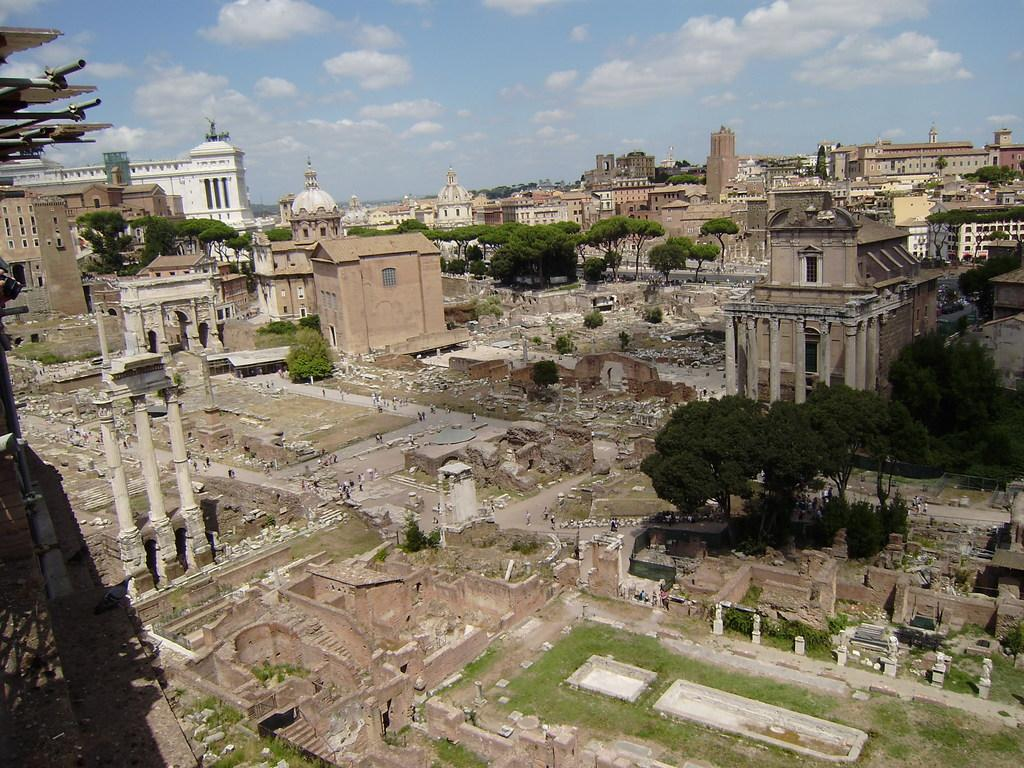What type of view is shown in the image? The image is an aerial view. What structures can be seen in the image? There are buildings, towers, and forts in the image. What natural elements are present in the image? Trees are present in the image. What man-made structures are visible in the image? There are poles and towers in the image. What is happening on the ground in the image? Vehicles are visible on the road, and there are people in the image. What is visible in the sky at the top of the image? Clouds are visible in the sky at the top of the image. What type of food is being served in the downtown area in the image? There is no downtown area or food being served in the image; it is an aerial view of a landscape with various structures and elements. 